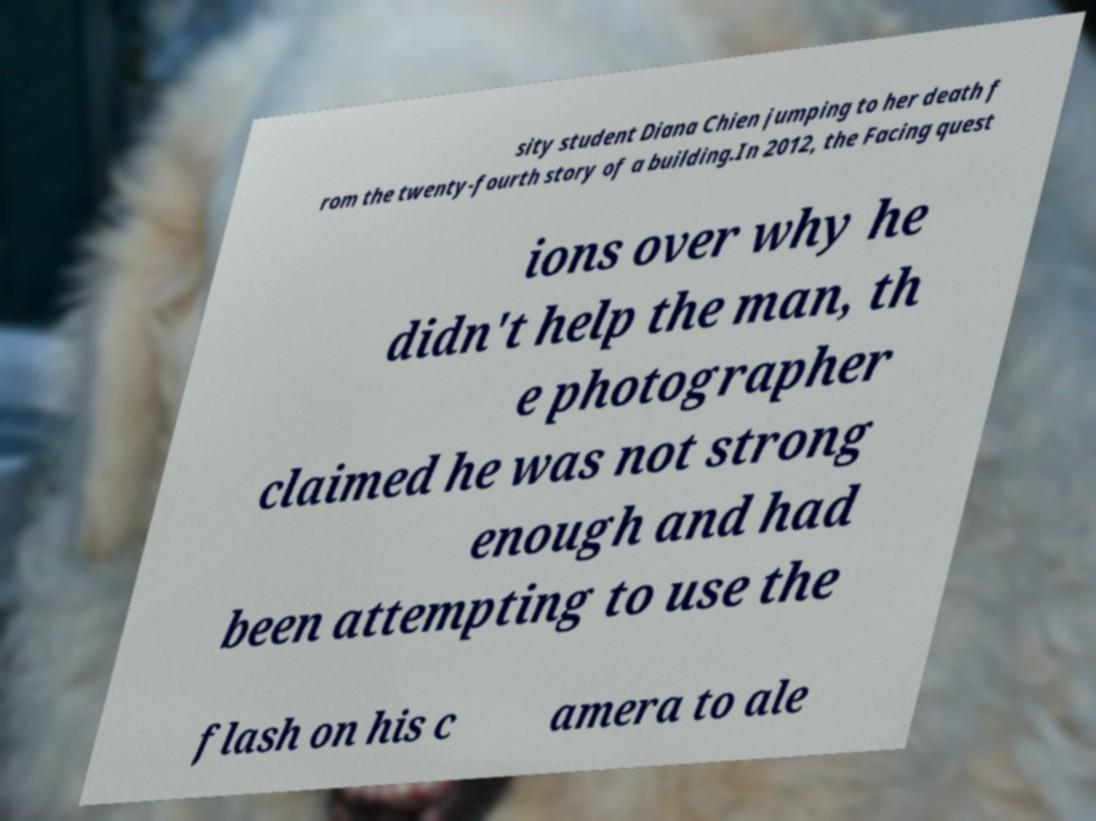For documentation purposes, I need the text within this image transcribed. Could you provide that? sity student Diana Chien jumping to her death f rom the twenty-fourth story of a building.In 2012, the Facing quest ions over why he didn't help the man, th e photographer claimed he was not strong enough and had been attempting to use the flash on his c amera to ale 